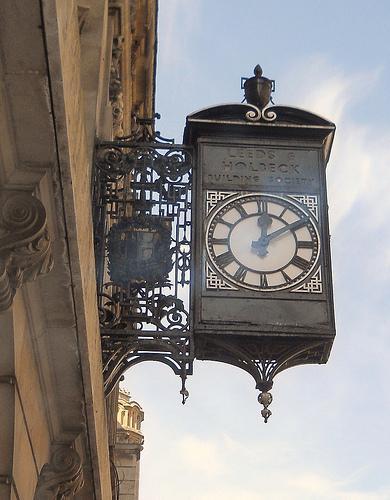How many clocks are there?
Give a very brief answer. 1. 